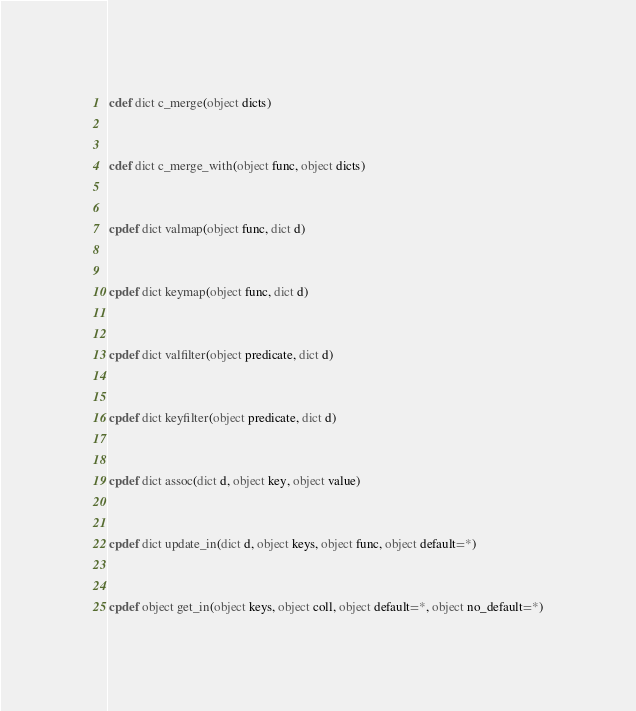<code> <loc_0><loc_0><loc_500><loc_500><_Cython_>cdef dict c_merge(object dicts)


cdef dict c_merge_with(object func, object dicts)


cpdef dict valmap(object func, dict d)


cpdef dict keymap(object func, dict d)


cpdef dict valfilter(object predicate, dict d)


cpdef dict keyfilter(object predicate, dict d)


cpdef dict assoc(dict d, object key, object value)


cpdef dict update_in(dict d, object keys, object func, object default=*)


cpdef object get_in(object keys, object coll, object default=*, object no_default=*)
</code> 